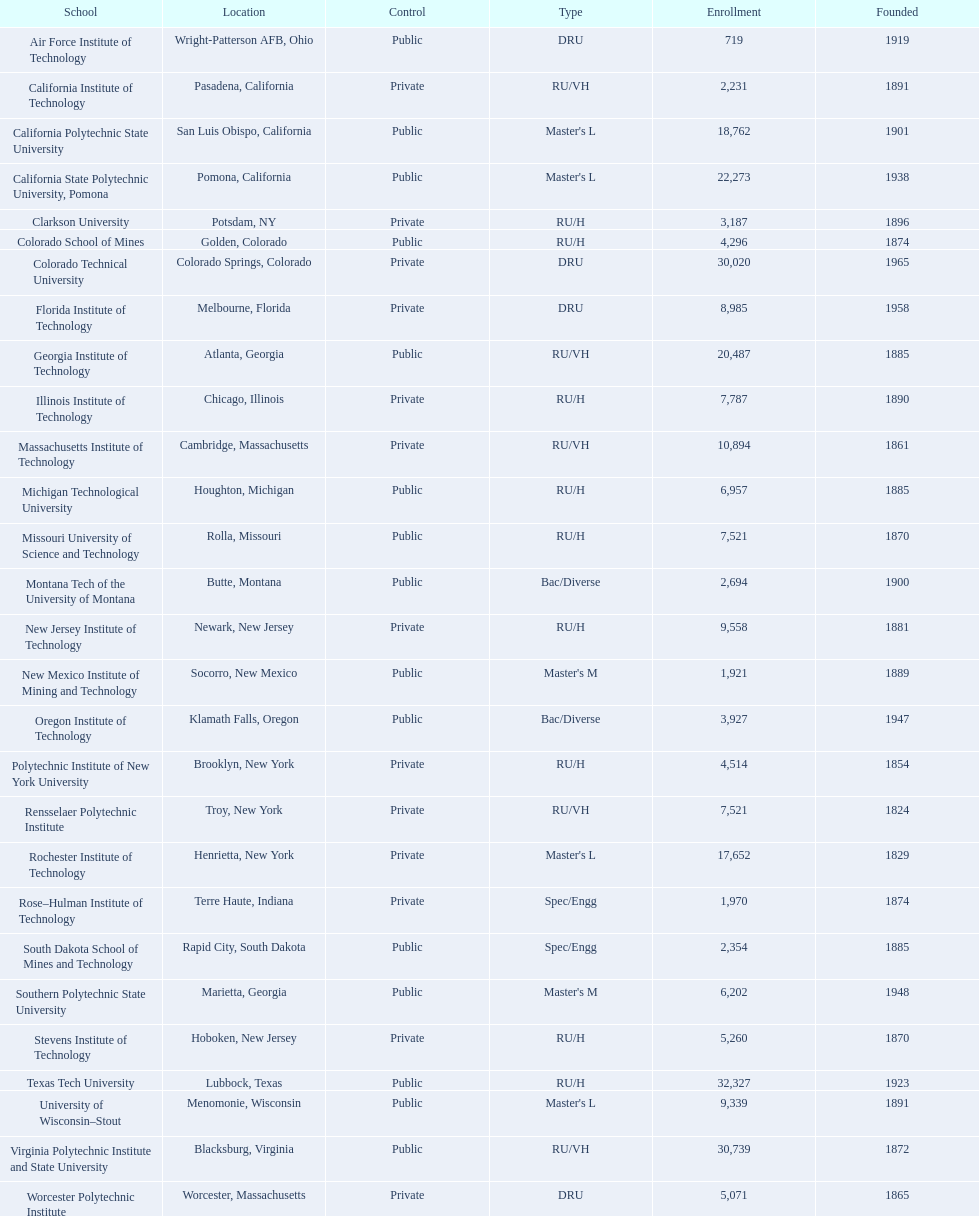Could you parse the entire table as a dict? {'header': ['School', 'Location', 'Control', 'Type', 'Enrollment', 'Founded'], 'rows': [['Air Force Institute of Technology', 'Wright-Patterson AFB, Ohio', 'Public', 'DRU', '719', '1919'], ['California Institute of Technology', 'Pasadena, California', 'Private', 'RU/VH', '2,231', '1891'], ['California Polytechnic State University', 'San Luis Obispo, California', 'Public', "Master's L", '18,762', '1901'], ['California State Polytechnic University, Pomona', 'Pomona, California', 'Public', "Master's L", '22,273', '1938'], ['Clarkson University', 'Potsdam, NY', 'Private', 'RU/H', '3,187', '1896'], ['Colorado School of Mines', 'Golden, Colorado', 'Public', 'RU/H', '4,296', '1874'], ['Colorado Technical University', 'Colorado Springs, Colorado', 'Private', 'DRU', '30,020', '1965'], ['Florida Institute of Technology', 'Melbourne, Florida', 'Private', 'DRU', '8,985', '1958'], ['Georgia Institute of Technology', 'Atlanta, Georgia', 'Public', 'RU/VH', '20,487', '1885'], ['Illinois Institute of Technology', 'Chicago, Illinois', 'Private', 'RU/H', '7,787', '1890'], ['Massachusetts Institute of Technology', 'Cambridge, Massachusetts', 'Private', 'RU/VH', '10,894', '1861'], ['Michigan Technological University', 'Houghton, Michigan', 'Public', 'RU/H', '6,957', '1885'], ['Missouri University of Science and Technology', 'Rolla, Missouri', 'Public', 'RU/H', '7,521', '1870'], ['Montana Tech of the University of Montana', 'Butte, Montana', 'Public', 'Bac/Diverse', '2,694', '1900'], ['New Jersey Institute of Technology', 'Newark, New Jersey', 'Private', 'RU/H', '9,558', '1881'], ['New Mexico Institute of Mining and Technology', 'Socorro, New Mexico', 'Public', "Master's M", '1,921', '1889'], ['Oregon Institute of Technology', 'Klamath Falls, Oregon', 'Public', 'Bac/Diverse', '3,927', '1947'], ['Polytechnic Institute of New York University', 'Brooklyn, New York', 'Private', 'RU/H', '4,514', '1854'], ['Rensselaer Polytechnic Institute', 'Troy, New York', 'Private', 'RU/VH', '7,521', '1824'], ['Rochester Institute of Technology', 'Henrietta, New York', 'Private', "Master's L", '17,652', '1829'], ['Rose–Hulman Institute of Technology', 'Terre Haute, Indiana', 'Private', 'Spec/Engg', '1,970', '1874'], ['South Dakota School of Mines and Technology', 'Rapid City, South Dakota', 'Public', 'Spec/Engg', '2,354', '1885'], ['Southern Polytechnic State University', 'Marietta, Georgia', 'Public', "Master's M", '6,202', '1948'], ['Stevens Institute of Technology', 'Hoboken, New Jersey', 'Private', 'RU/H', '5,260', '1870'], ['Texas Tech University', 'Lubbock, Texas', 'Public', 'RU/H', '32,327', '1923'], ['University of Wisconsin–Stout', 'Menomonie, Wisconsin', 'Public', "Master's L", '9,339', '1891'], ['Virginia Polytechnic Institute and State University', 'Blacksburg, Virginia', 'Public', 'RU/VH', '30,739', '1872'], ['Worcester Polytechnic Institute', 'Worcester, Massachusetts', 'Private', 'DRU', '5,071', '1865']]} How many of the educational institutions were situated in california? 3. 